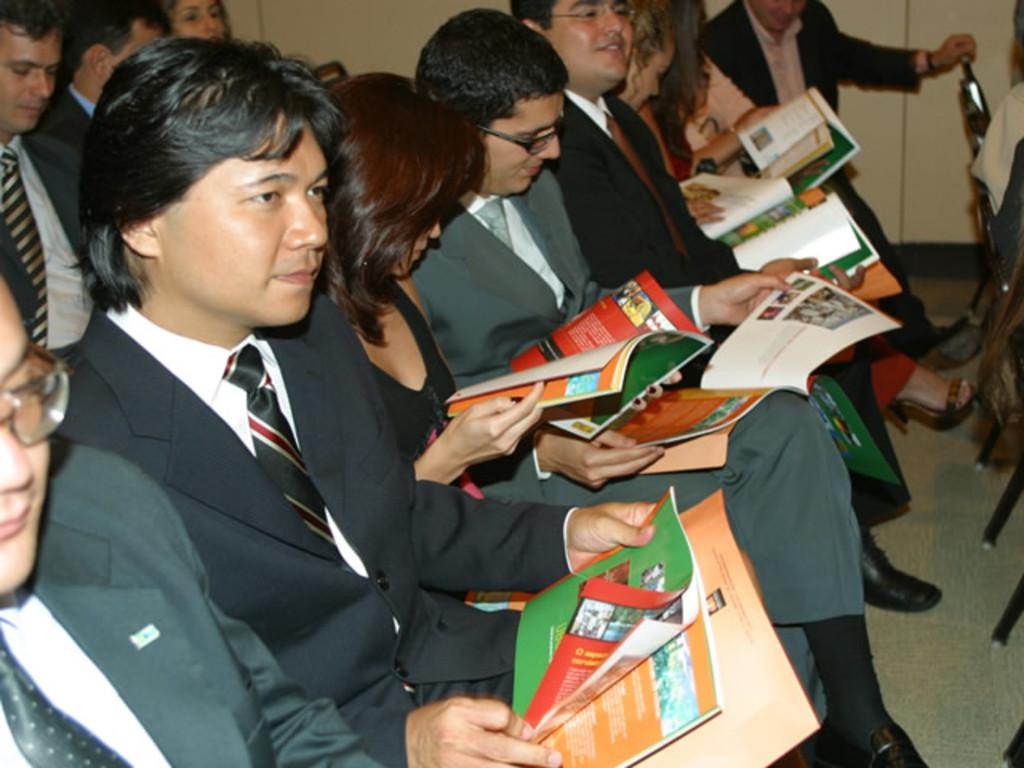What is happening in the image? There is a group of people in the image. What are the people doing in the image? The people are sitting on chairs. Are the people holding anything in the image? Some people are holding books. What can be seen behind the people in the image? There is a wall behind the people. How many lizards are crawling on the elbow of the person holding a book in the image? There are no lizards present in the image. 